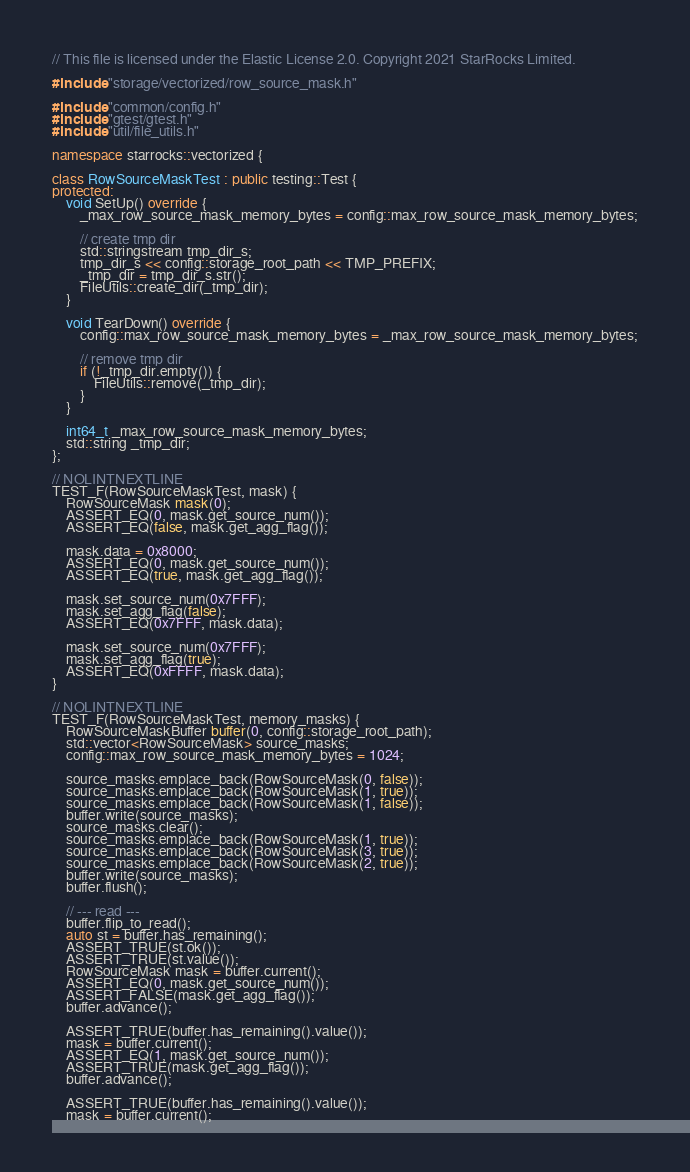<code> <loc_0><loc_0><loc_500><loc_500><_C++_>// This file is licensed under the Elastic License 2.0. Copyright 2021 StarRocks Limited.

#include "storage/vectorized/row_source_mask.h"

#include "common/config.h"
#include "gtest/gtest.h"
#include "util/file_utils.h"

namespace starrocks::vectorized {

class RowSourceMaskTest : public testing::Test {
protected:
    void SetUp() override {
        _max_row_source_mask_memory_bytes = config::max_row_source_mask_memory_bytes;

        // create tmp dir
        std::stringstream tmp_dir_s;
        tmp_dir_s << config::storage_root_path << TMP_PREFIX;
        _tmp_dir = tmp_dir_s.str();
        FileUtils::create_dir(_tmp_dir);
    }

    void TearDown() override {
        config::max_row_source_mask_memory_bytes = _max_row_source_mask_memory_bytes;

        // remove tmp dir
        if (!_tmp_dir.empty()) {
            FileUtils::remove(_tmp_dir);
        }
    }

    int64_t _max_row_source_mask_memory_bytes;
    std::string _tmp_dir;
};

// NOLINTNEXTLINE
TEST_F(RowSourceMaskTest, mask) {
    RowSourceMask mask(0);
    ASSERT_EQ(0, mask.get_source_num());
    ASSERT_EQ(false, mask.get_agg_flag());

    mask.data = 0x8000;
    ASSERT_EQ(0, mask.get_source_num());
    ASSERT_EQ(true, mask.get_agg_flag());

    mask.set_source_num(0x7FFF);
    mask.set_agg_flag(false);
    ASSERT_EQ(0x7FFF, mask.data);

    mask.set_source_num(0x7FFF);
    mask.set_agg_flag(true);
    ASSERT_EQ(0xFFFF, mask.data);
}

// NOLINTNEXTLINE
TEST_F(RowSourceMaskTest, memory_masks) {
    RowSourceMaskBuffer buffer(0, config::storage_root_path);
    std::vector<RowSourceMask> source_masks;
    config::max_row_source_mask_memory_bytes = 1024;

    source_masks.emplace_back(RowSourceMask(0, false));
    source_masks.emplace_back(RowSourceMask(1, true));
    source_masks.emplace_back(RowSourceMask(1, false));
    buffer.write(source_masks);
    source_masks.clear();
    source_masks.emplace_back(RowSourceMask(1, true));
    source_masks.emplace_back(RowSourceMask(3, true));
    source_masks.emplace_back(RowSourceMask(2, true));
    buffer.write(source_masks);
    buffer.flush();

    // --- read ---
    buffer.flip_to_read();
    auto st = buffer.has_remaining();
    ASSERT_TRUE(st.ok());
    ASSERT_TRUE(st.value());
    RowSourceMask mask = buffer.current();
    ASSERT_EQ(0, mask.get_source_num());
    ASSERT_FALSE(mask.get_agg_flag());
    buffer.advance();

    ASSERT_TRUE(buffer.has_remaining().value());
    mask = buffer.current();
    ASSERT_EQ(1, mask.get_source_num());
    ASSERT_TRUE(mask.get_agg_flag());
    buffer.advance();

    ASSERT_TRUE(buffer.has_remaining().value());
    mask = buffer.current();</code> 